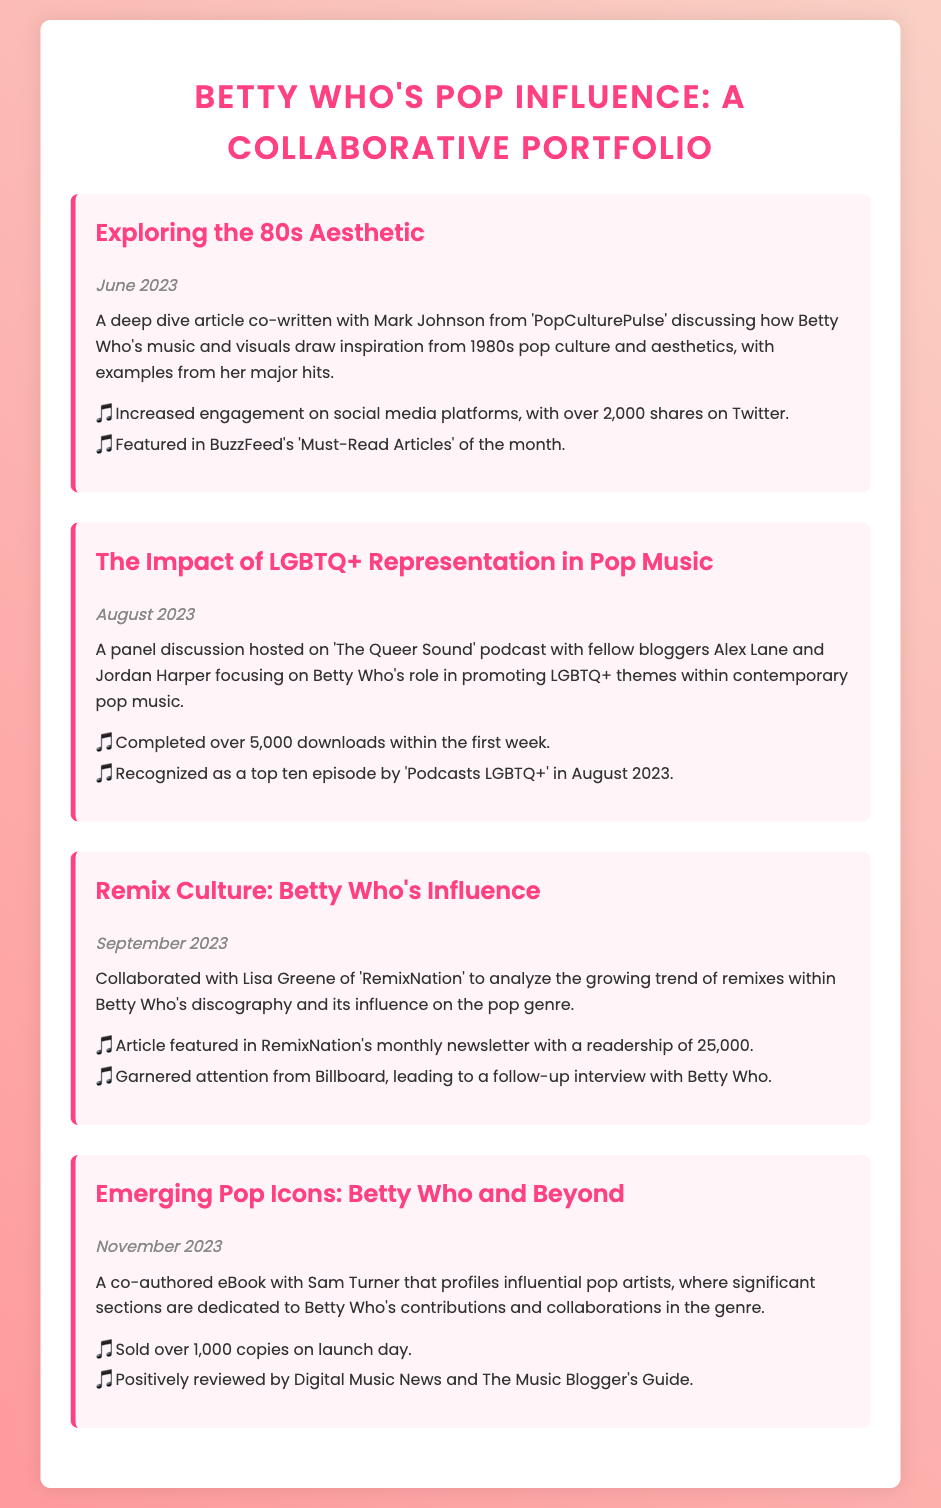what is the title of the portfolio? The title of the portfolio is provided at the top of the document and focuses on Betty Who's influence on pop music.
Answer: Betty Who's Pop Influence: A Collaborative Portfolio who co-wrote the article on 80s aesthetics? The co-writer of the article discussing 80s aesthetics is named Mark Johnson, indicating collaborative effort.
Answer: Mark Johnson how many downloads did the podcast episode receive in the first week? The document states the number of downloads achieved by the podcast episode, reflecting its popularity.
Answer: 5,000 downloads what was the release date of the eBook? The date mentioned for the release of the eBook authored with Sam Turner reflects its timeliness within the context of pop culture.
Answer: November 2023 how many copies of the eBook were sold on launch day? The launch day sales of the eBook illustrate its immediate success and reception by the audience.
Answer: 1,000 copies what is the theme of the panel discussion podcast? The focus of the panel discussion highlights a significant cultural issue within the music industry, showcasing Betty Who's influence.
Answer: LGBTQ+ Representation in Pop Music which platform featured the article on remix culture? The platform mentioned as the publisher of the article examining remix culture highlights its reach within the music community.
Answer: RemixNation what was recognized as a top ten episode in August 2023? The specific episode mentioned in the document received notable recognition, showcasing its impact in the podcasting community.
Answer: The Impact of LGBTQ+ Representation in Pop Music 